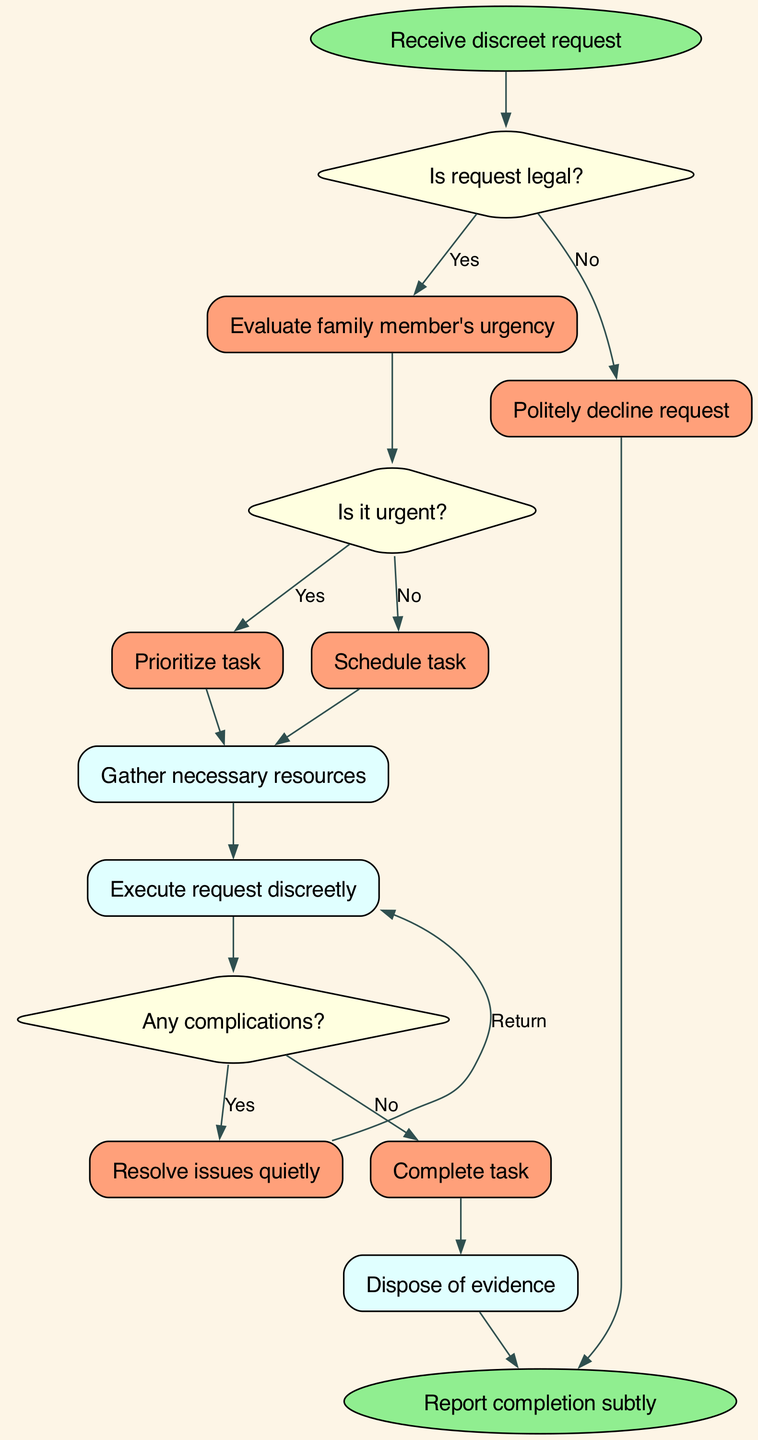What is the first action taken after receiving a discreet request? The first action shown in the diagram is "Receive discreet request" which initiates the process.
Answer: Receive discreet request What happens if the request is not legal? According to the diagram, if the request is not legal, the action taken is "Politely decline request."
Answer: Politely decline request How many decision nodes are there in the diagram? The diagram includes three decision nodes: decision1, decision2, and decision3. Thus, the total count is three.
Answer: Three If the request is deemed urgent, what is the immediate next process? If the request is urgent, the immediate next process after evaluating urgency is "Prioritize task."
Answer: Prioritize task What follows the action of "Execute request discreetly" if complications arise? If complications arise after executing the request, the next action is to "Resolve issues quietly."
Answer: Resolve issues quietly What do you do after gathering necessary resources regardless of the urgency of the request? After gathering necessary resources, the following step is to "Execute request discreetly."
Answer: Execute request discreetly What is the final outcome in the flow? The final outcome reached in the flow is "Report completion subtly."
Answer: Report completion subtly If the request is not urgent, what subsequent action should be taken? If the request is not urgent, it will be "Schedule task" for a later time.
Answer: Schedule task What is done after determining there are no complications post-execution? If there are no complications, the subsequent action is to "Complete task."
Answer: Complete task 